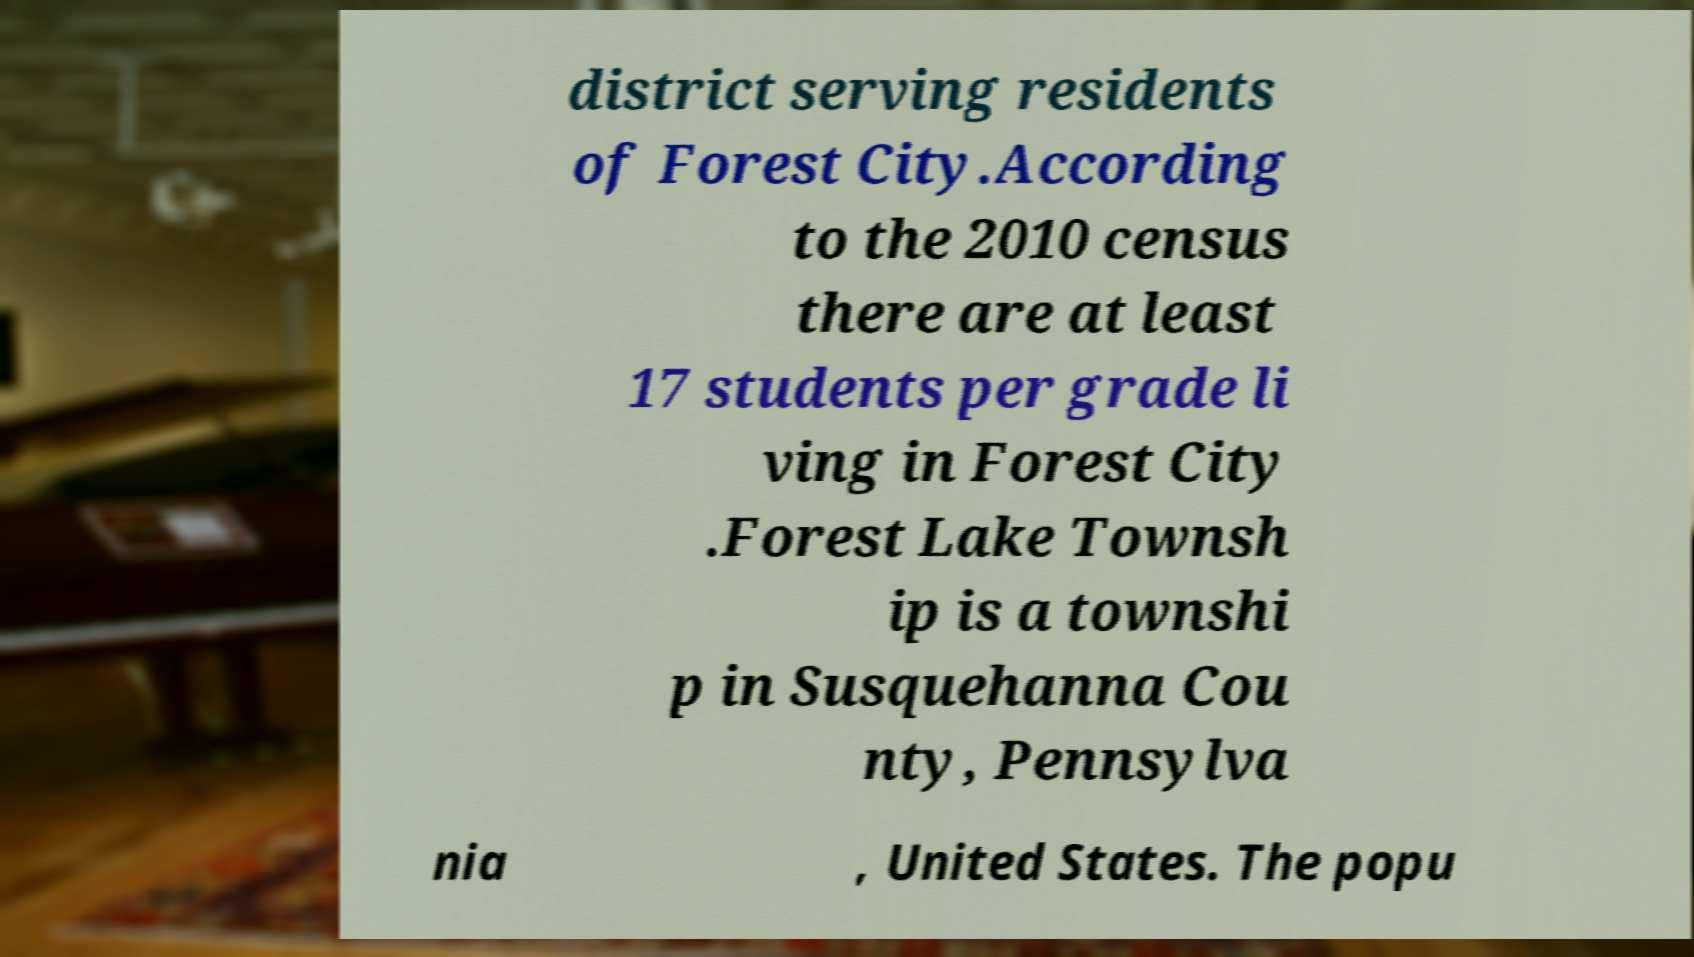There's text embedded in this image that I need extracted. Can you transcribe it verbatim? district serving residents of Forest City.According to the 2010 census there are at least 17 students per grade li ving in Forest City .Forest Lake Townsh ip is a townshi p in Susquehanna Cou nty, Pennsylva nia , United States. The popu 